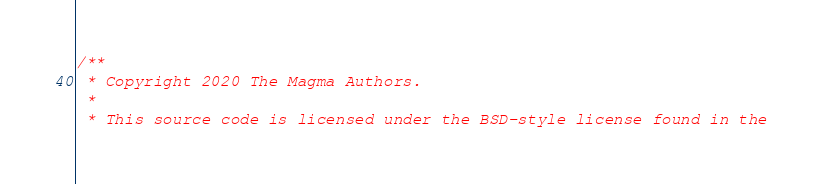Convert code to text. <code><loc_0><loc_0><loc_500><loc_500><_C++_>/**
 * Copyright 2020 The Magma Authors.
 *
 * This source code is licensed under the BSD-style license found in the</code> 